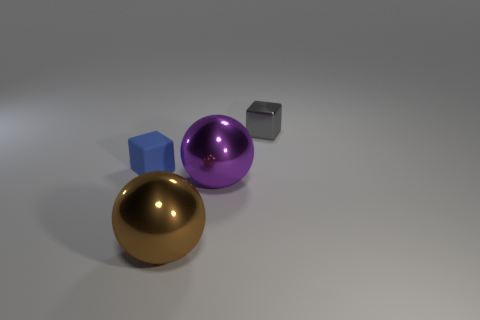Are there any other things that have the same material as the small blue thing?
Provide a short and direct response. No. What is the material of the large purple object?
Your answer should be very brief. Metal. Is the shape of the big thing behind the brown ball the same as  the small blue rubber thing?
Your response must be concise. No. Is there a rubber thing that has the same size as the purple metal ball?
Your answer should be compact. No. There is a tiny object in front of the thing right of the purple shiny thing; is there a big purple object that is to the right of it?
Keep it short and to the point. Yes. Do the tiny rubber block and the tiny cube to the right of the tiny rubber thing have the same color?
Give a very brief answer. No. What is the material of the tiny cube in front of the object behind the tiny object that is on the left side of the brown shiny object?
Provide a succinct answer. Rubber. What shape is the small gray thing behind the purple sphere?
Your answer should be very brief. Cube. What size is the purple object that is made of the same material as the brown sphere?
Your answer should be very brief. Large. How many tiny gray objects have the same shape as the small blue thing?
Keep it short and to the point. 1. 